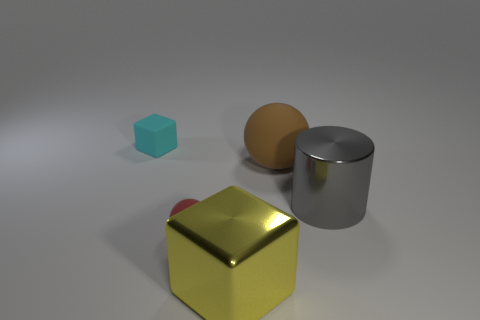What size is the object behind the sphere to the right of the tiny object in front of the small cyan matte thing? The object behind the sphere and to the right of the tiny object in front of the small cyan cube appears to be a medium-sized matte cylinder. 